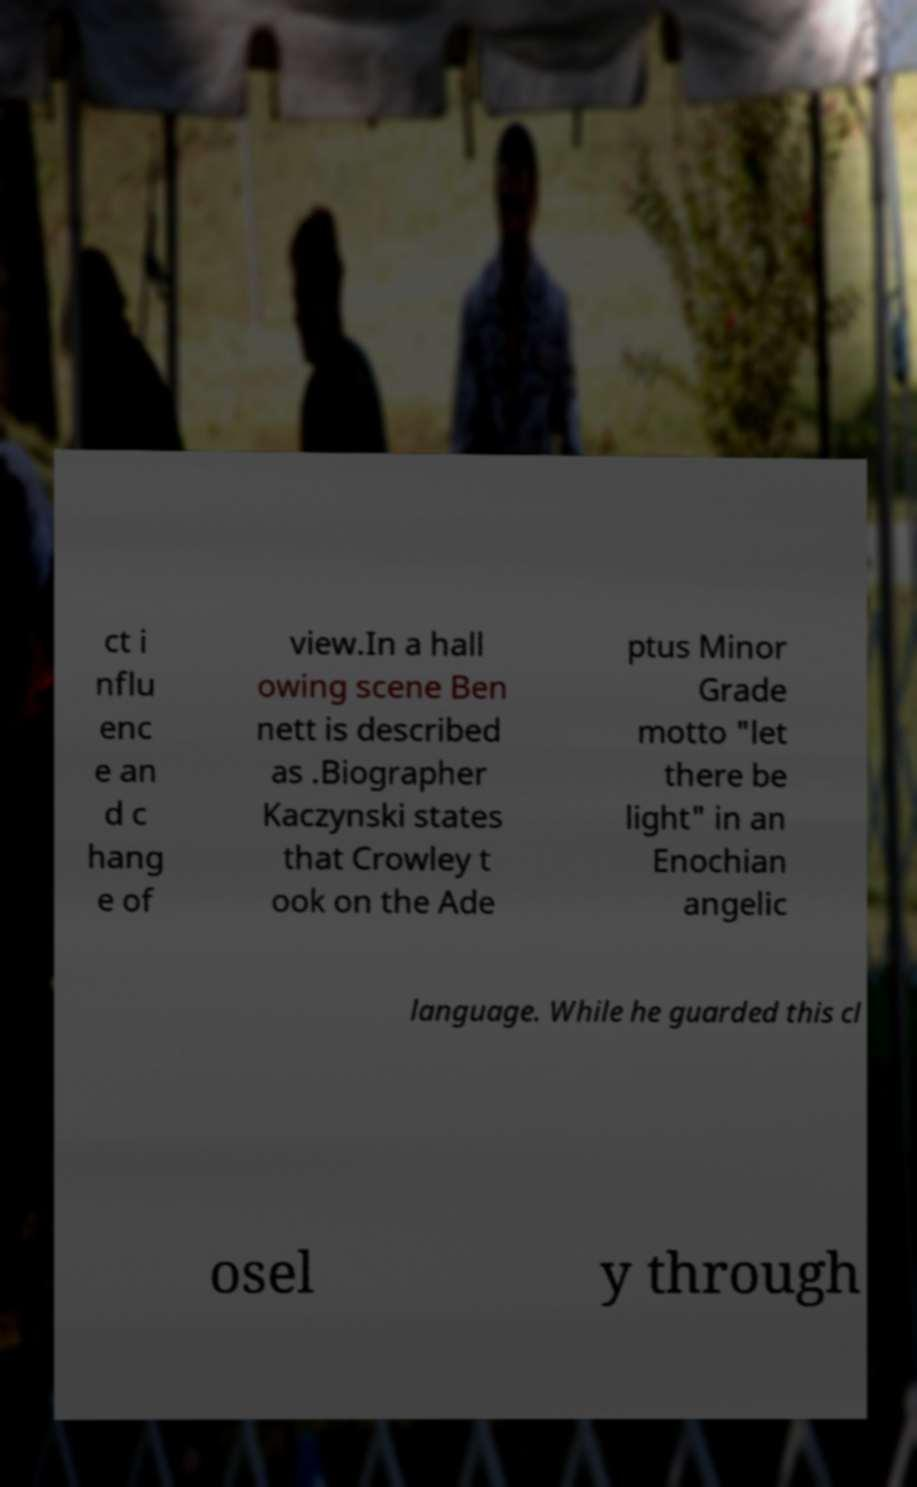Please identify and transcribe the text found in this image. ct i nflu enc e an d c hang e of view.In a hall owing scene Ben nett is described as .Biographer Kaczynski states that Crowley t ook on the Ade ptus Minor Grade motto "let there be light" in an Enochian angelic language. While he guarded this cl osel y through 